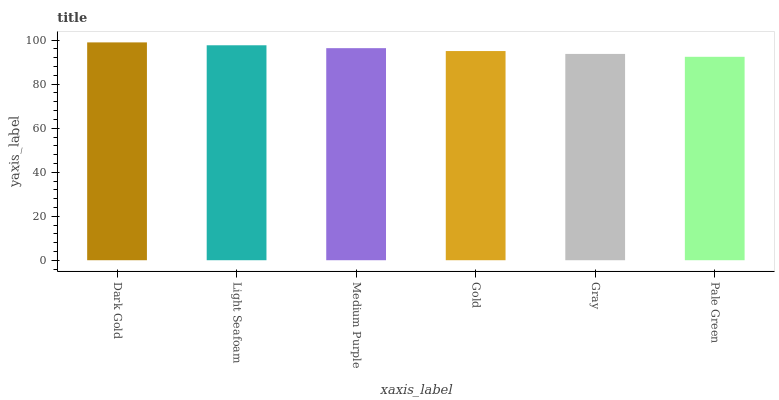Is Pale Green the minimum?
Answer yes or no. Yes. Is Dark Gold the maximum?
Answer yes or no. Yes. Is Light Seafoam the minimum?
Answer yes or no. No. Is Light Seafoam the maximum?
Answer yes or no. No. Is Dark Gold greater than Light Seafoam?
Answer yes or no. Yes. Is Light Seafoam less than Dark Gold?
Answer yes or no. Yes. Is Light Seafoam greater than Dark Gold?
Answer yes or no. No. Is Dark Gold less than Light Seafoam?
Answer yes or no. No. Is Medium Purple the high median?
Answer yes or no. Yes. Is Gold the low median?
Answer yes or no. Yes. Is Pale Green the high median?
Answer yes or no. No. Is Dark Gold the low median?
Answer yes or no. No. 